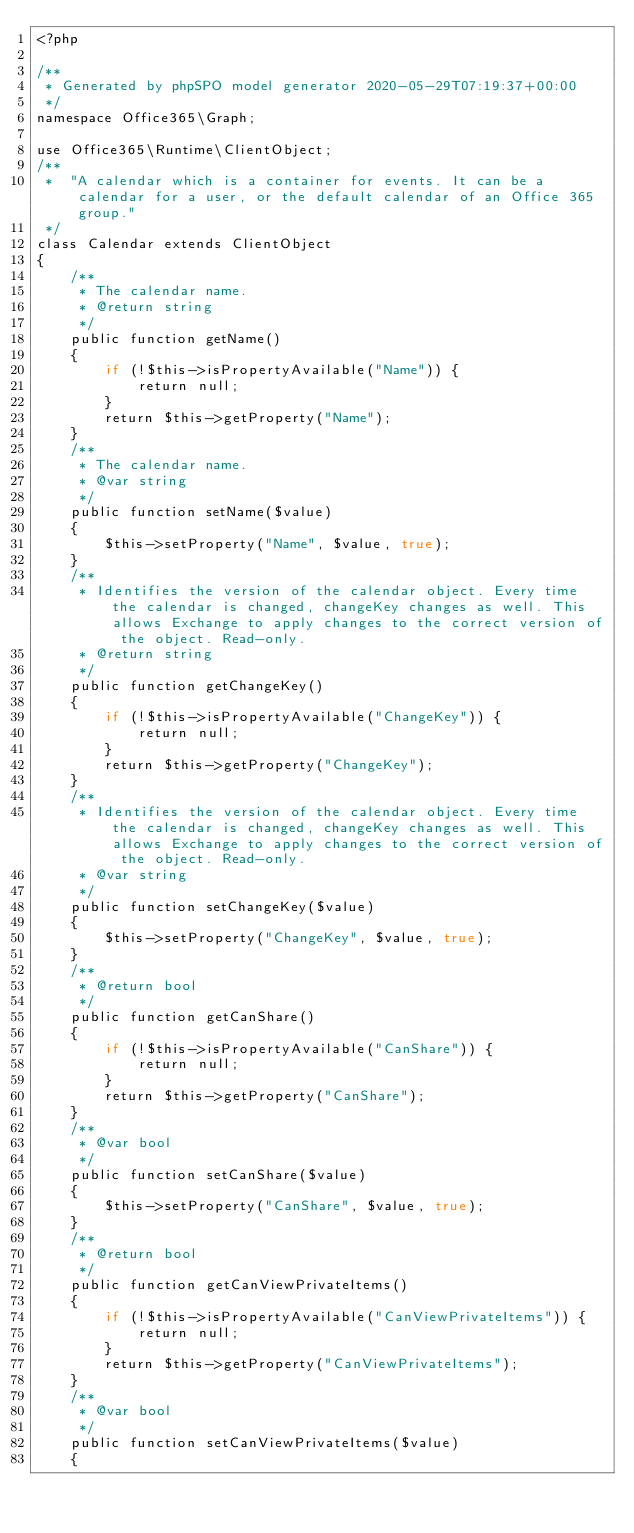Convert code to text. <code><loc_0><loc_0><loc_500><loc_500><_PHP_><?php

/**
 * Generated by phpSPO model generator 2020-05-29T07:19:37+00:00 
 */
namespace Office365\Graph;

use Office365\Runtime\ClientObject;
/**
 *  "A calendar which is a container for events. It can be a calendar for a user, or the default calendar of an Office 365 group."
 */
class Calendar extends ClientObject
{
    /**
     * The calendar name.
     * @return string
     */
    public function getName()
    {
        if (!$this->isPropertyAvailable("Name")) {
            return null;
        }
        return $this->getProperty("Name");
    }
    /**
     * The calendar name.
     * @var string
     */
    public function setName($value)
    {
        $this->setProperty("Name", $value, true);
    }
    /**
     * Identifies the version of the calendar object. Every time the calendar is changed, changeKey changes as well. This allows Exchange to apply changes to the correct version of the object. Read-only.
     * @return string
     */
    public function getChangeKey()
    {
        if (!$this->isPropertyAvailable("ChangeKey")) {
            return null;
        }
        return $this->getProperty("ChangeKey");
    }
    /**
     * Identifies the version of the calendar object. Every time the calendar is changed, changeKey changes as well. This allows Exchange to apply changes to the correct version of the object. Read-only.
     * @var string
     */
    public function setChangeKey($value)
    {
        $this->setProperty("ChangeKey", $value, true);
    }
    /**
     * @return bool
     */
    public function getCanShare()
    {
        if (!$this->isPropertyAvailable("CanShare")) {
            return null;
        }
        return $this->getProperty("CanShare");
    }
    /**
     * @var bool
     */
    public function setCanShare($value)
    {
        $this->setProperty("CanShare", $value, true);
    }
    /**
     * @return bool
     */
    public function getCanViewPrivateItems()
    {
        if (!$this->isPropertyAvailable("CanViewPrivateItems")) {
            return null;
        }
        return $this->getProperty("CanViewPrivateItems");
    }
    /**
     * @var bool
     */
    public function setCanViewPrivateItems($value)
    {</code> 